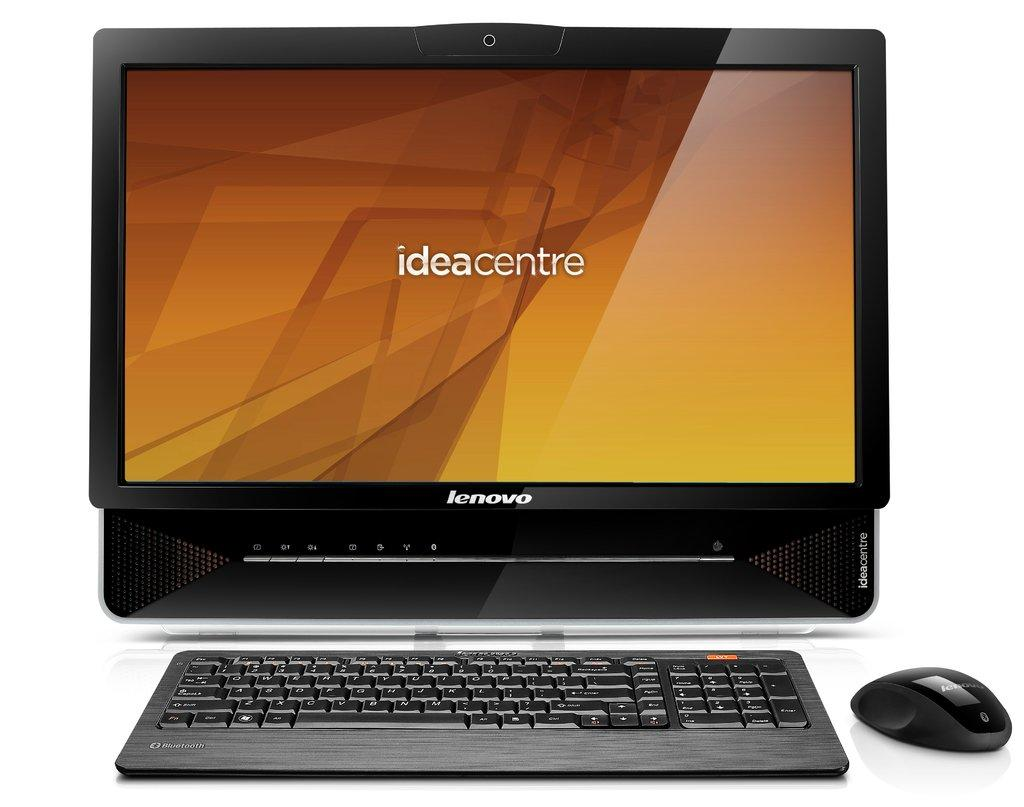Provide a one-sentence caption for the provided image. Lenovo desktop computer which is of the ideacentre model. 